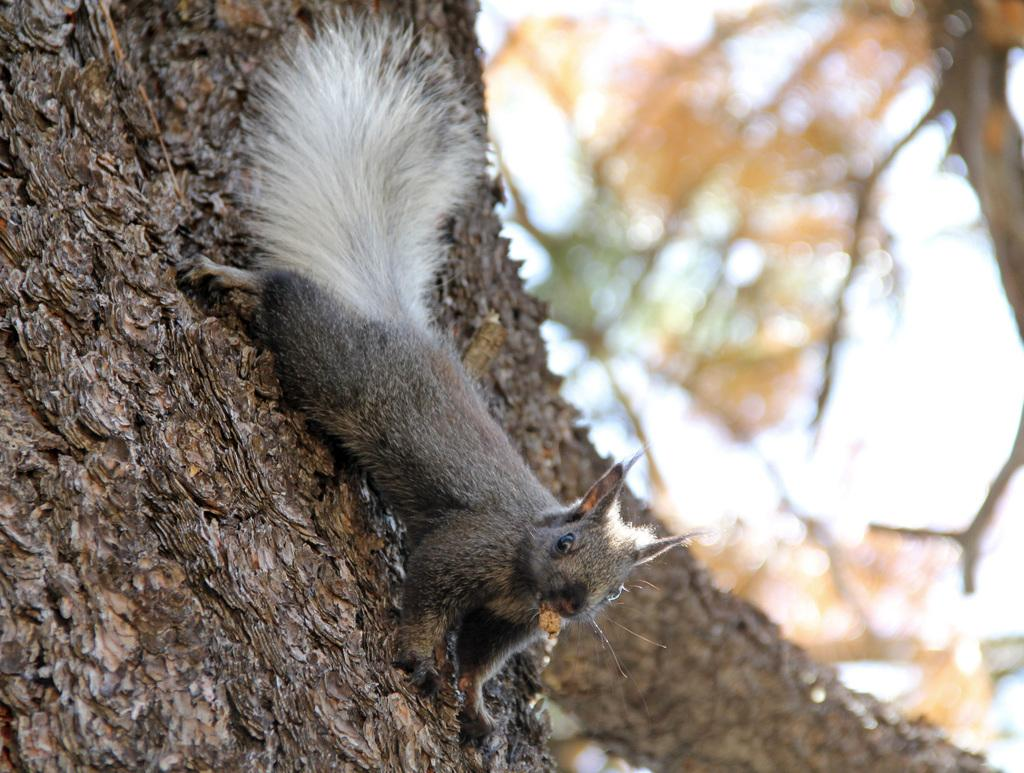What type of animal can be seen in the image? There is an animal in the image, but its specific type cannot be determined from the provided facts. Where is the animal located in the image? The animal is on a tree in the image. What can be seen in the background of the image? There are trees in the background of the image. Can you tell me how many snakes are wrapped around the stranger in the image? There is no stranger or snakes present in the image; it features an animal on a tree with trees in the background. 